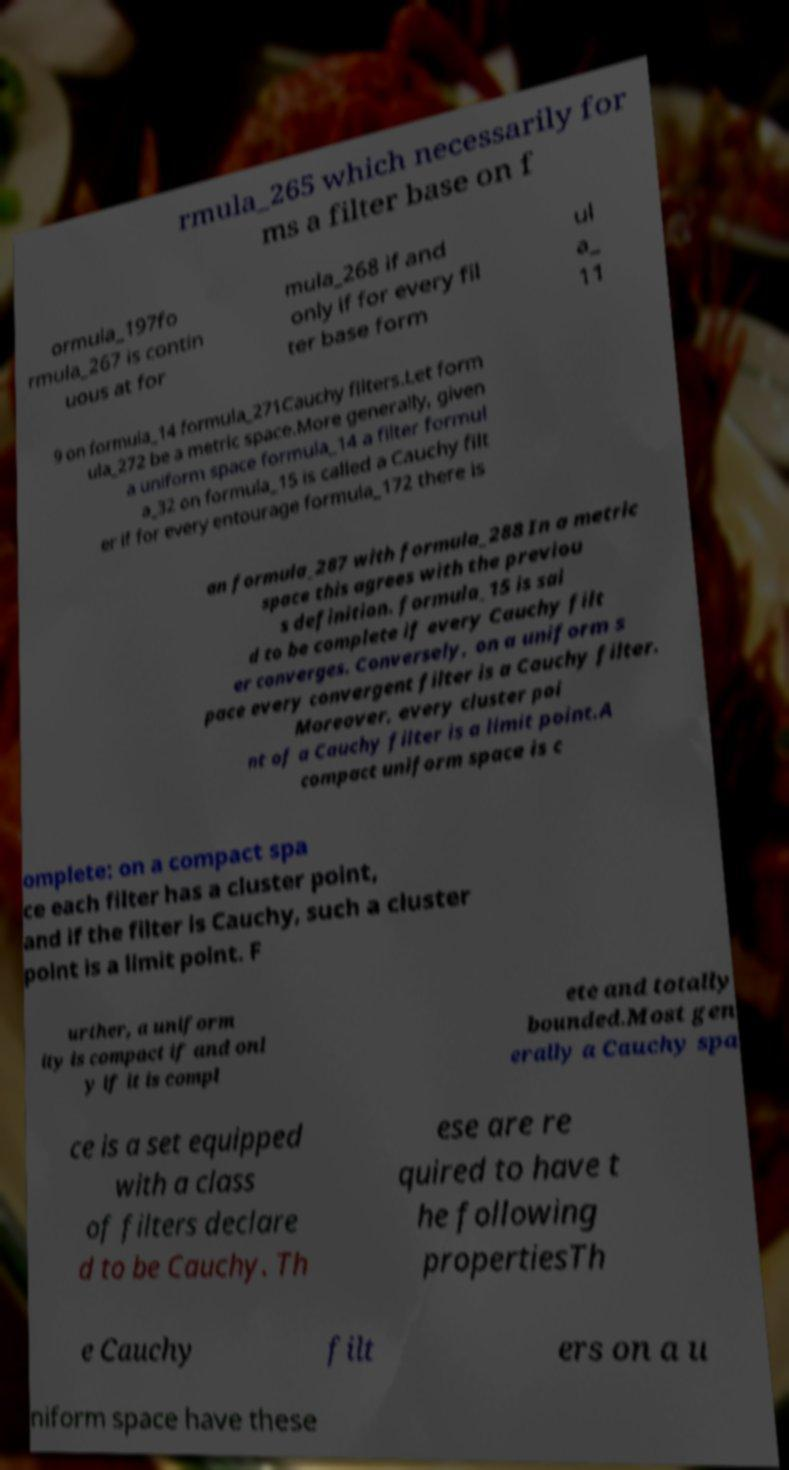Please read and relay the text visible in this image. What does it say? rmula_265 which necessarily for ms a filter base on f ormula_197fo rmula_267 is contin uous at for mula_268 if and only if for every fil ter base form ul a_ 11 9 on formula_14 formula_271Cauchy filters.Let form ula_272 be a metric space.More generally, given a uniform space formula_14 a filter formul a_32 on formula_15 is called a Cauchy filt er if for every entourage formula_172 there is an formula_287 with formula_288 In a metric space this agrees with the previou s definition. formula_15 is sai d to be complete if every Cauchy filt er converges. Conversely, on a uniform s pace every convergent filter is a Cauchy filter. Moreover, every cluster poi nt of a Cauchy filter is a limit point.A compact uniform space is c omplete: on a compact spa ce each filter has a cluster point, and if the filter is Cauchy, such a cluster point is a limit point. F urther, a uniform ity is compact if and onl y if it is compl ete and totally bounded.Most gen erally a Cauchy spa ce is a set equipped with a class of filters declare d to be Cauchy. Th ese are re quired to have t he following propertiesTh e Cauchy filt ers on a u niform space have these 